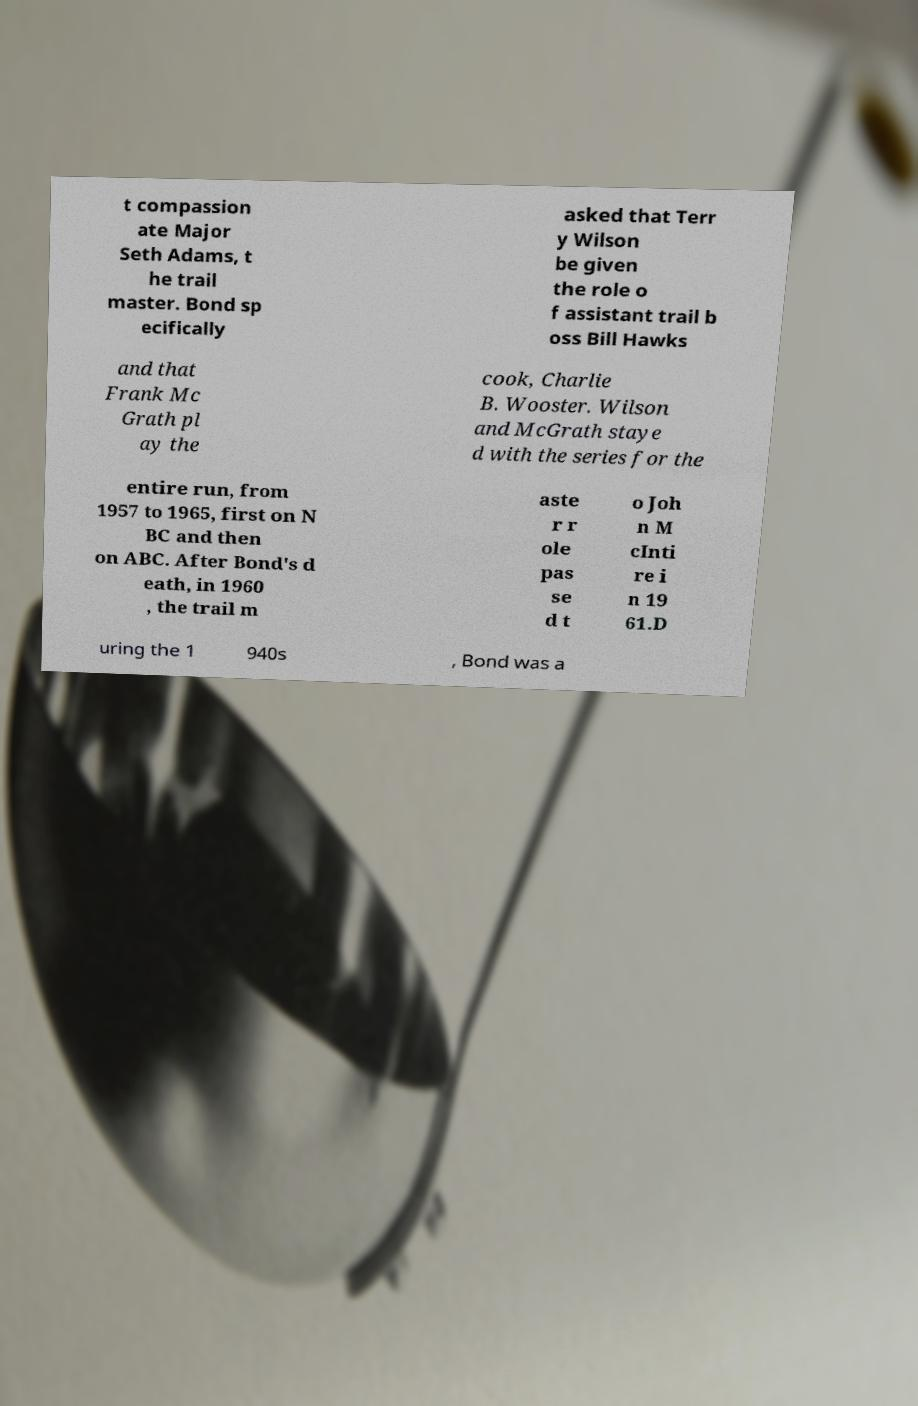Please identify and transcribe the text found in this image. t compassion ate Major Seth Adams, t he trail master. Bond sp ecifically asked that Terr y Wilson be given the role o f assistant trail b oss Bill Hawks and that Frank Mc Grath pl ay the cook, Charlie B. Wooster. Wilson and McGrath staye d with the series for the entire run, from 1957 to 1965, first on N BC and then on ABC. After Bond's d eath, in 1960 , the trail m aste r r ole pas se d t o Joh n M cInti re i n 19 61.D uring the 1 940s , Bond was a 